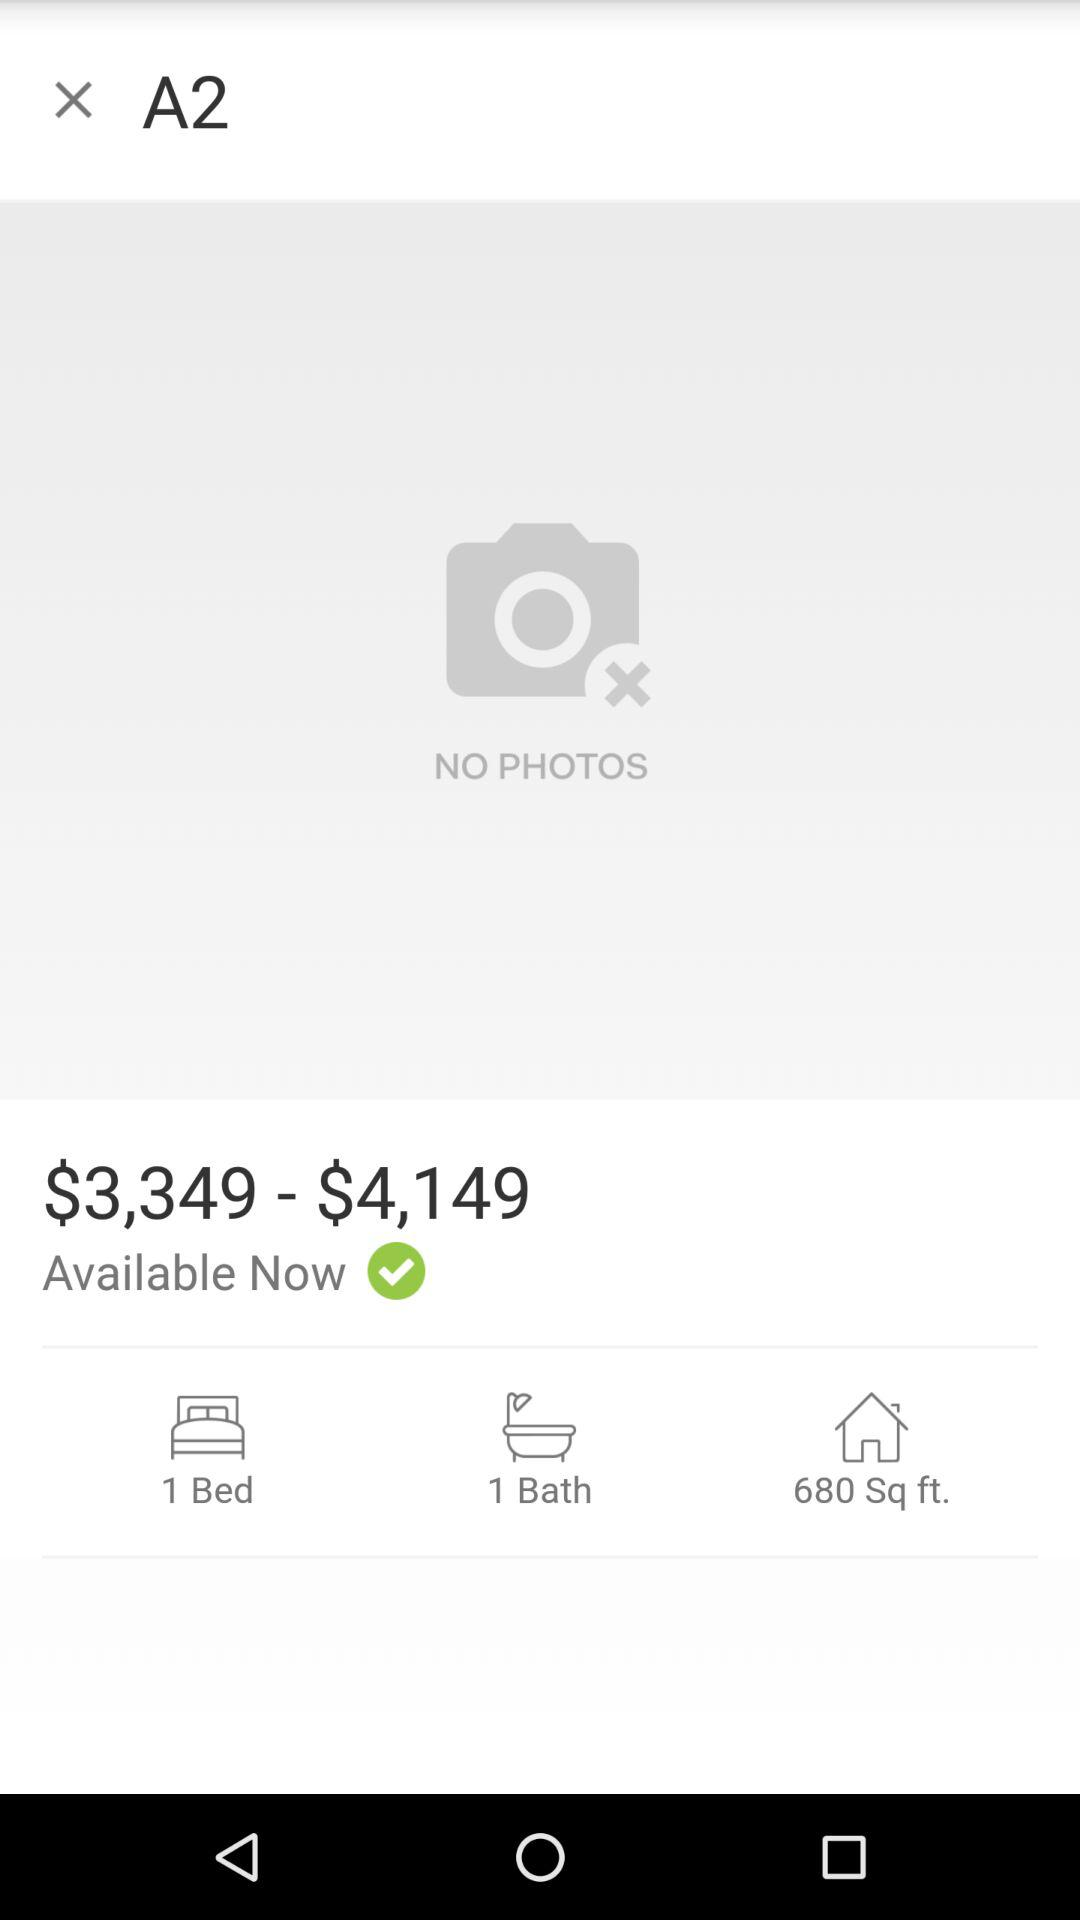What is the number of beds? The number of beds is 1. 